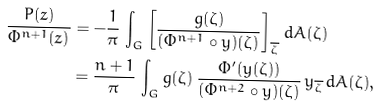Convert formula to latex. <formula><loc_0><loc_0><loc_500><loc_500>\frac { P ( z ) } { \Phi ^ { n + 1 } ( z ) } & = - \frac { 1 } { \pi } \, \int _ { G } \left [ \frac { g ( \zeta ) } { ( \Phi ^ { n + 1 } \circ y ) ( \zeta ) } \right ] _ { \overline { \zeta } } \, d A ( \zeta ) \\ & = \frac { n + 1 } { \pi } \, \int _ { G } g ( \zeta ) \, \frac { \Phi ^ { \prime } ( y ( \zeta ) ) } { ( \Phi ^ { n + 2 } \circ y ) ( \zeta ) } \, y _ { \overline { \zeta } } \, d A ( \zeta ) ,</formula> 